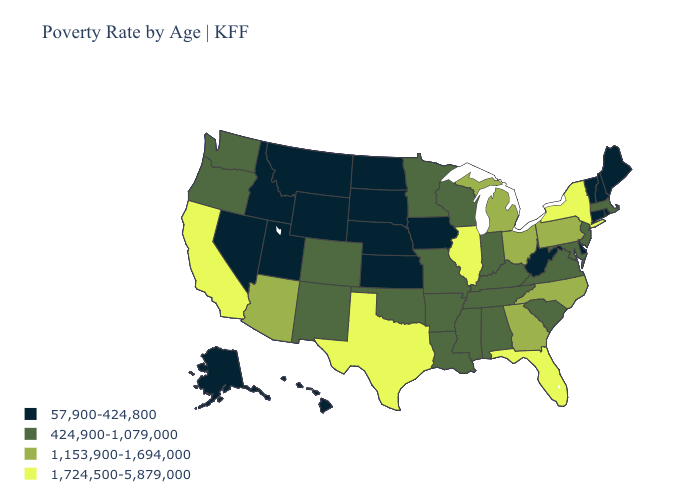What is the highest value in the USA?
Concise answer only. 1,724,500-5,879,000. Does the map have missing data?
Keep it brief. No. Name the states that have a value in the range 1,153,900-1,694,000?
Give a very brief answer. Arizona, Georgia, Michigan, North Carolina, Ohio, Pennsylvania. Name the states that have a value in the range 57,900-424,800?
Keep it brief. Alaska, Connecticut, Delaware, Hawaii, Idaho, Iowa, Kansas, Maine, Montana, Nebraska, Nevada, New Hampshire, North Dakota, Rhode Island, South Dakota, Utah, Vermont, West Virginia, Wyoming. Does the first symbol in the legend represent the smallest category?
Answer briefly. Yes. What is the highest value in the USA?
Give a very brief answer. 1,724,500-5,879,000. Does the first symbol in the legend represent the smallest category?
Quick response, please. Yes. Name the states that have a value in the range 1,724,500-5,879,000?
Be succinct. California, Florida, Illinois, New York, Texas. Does Ohio have the lowest value in the USA?
Keep it brief. No. Is the legend a continuous bar?
Give a very brief answer. No. Among the states that border Nevada , does California have the highest value?
Be succinct. Yes. Does Kansas have the lowest value in the MidWest?
Short answer required. Yes. Name the states that have a value in the range 57,900-424,800?
Be succinct. Alaska, Connecticut, Delaware, Hawaii, Idaho, Iowa, Kansas, Maine, Montana, Nebraska, Nevada, New Hampshire, North Dakota, Rhode Island, South Dakota, Utah, Vermont, West Virginia, Wyoming. What is the value of Maryland?
Write a very short answer. 424,900-1,079,000. 